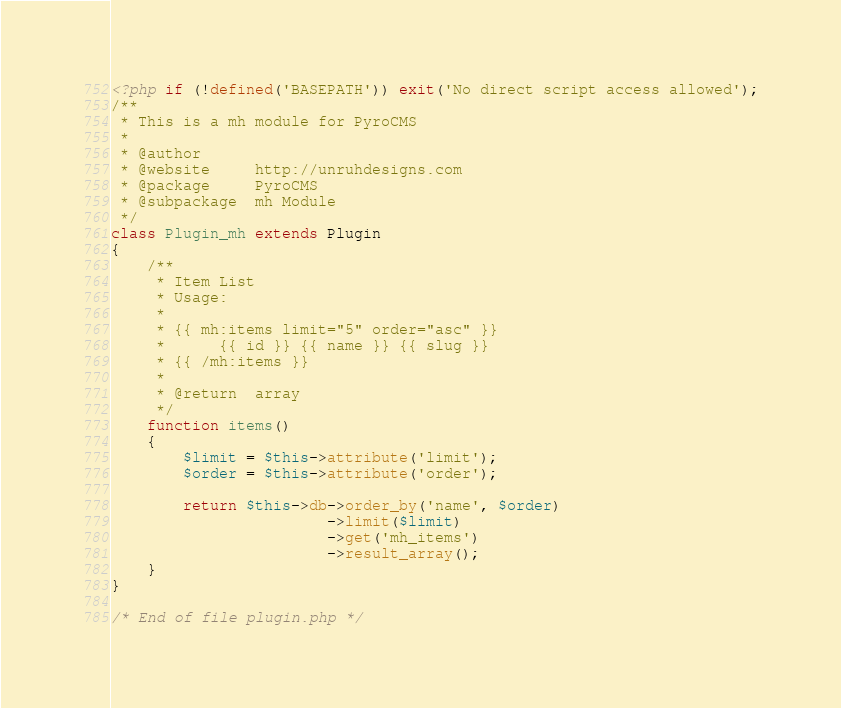Convert code to text. <code><loc_0><loc_0><loc_500><loc_500><_PHP_><?php if (!defined('BASEPATH')) exit('No direct script access allowed');
/**
 * This is a mh module for PyroCMS
 *
 * @author 		
 * @website		http://unruhdesigns.com
 * @package 	PyroCMS
 * @subpackage 	mh Module
 */
class Plugin_mh extends Plugin
{
	/**
	 * Item List
	 * Usage:
	 * 
	 * {{ mh:items limit="5" order="asc" }}
	 *      {{ id }} {{ name }} {{ slug }}
	 * {{ /mh:items }}
	 *
	 * @return	array
	 */
	function items()
	{
		$limit = $this->attribute('limit');
		$order = $this->attribute('order');
		
		return $this->db->order_by('name', $order)
						->limit($limit)
						->get('mh_items')
						->result_array();
	}
}

/* End of file plugin.php */
</code> 